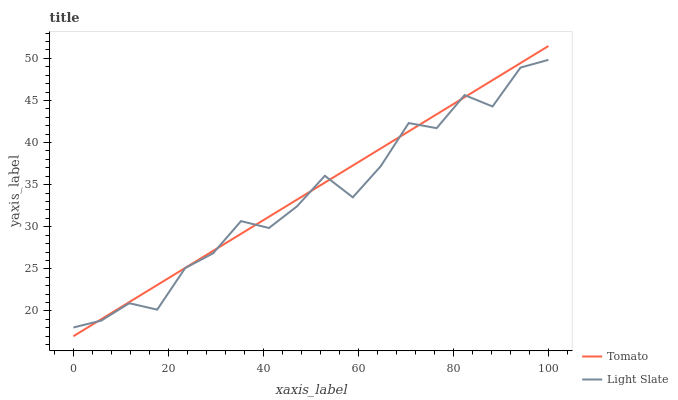Does Light Slate have the minimum area under the curve?
Answer yes or no. Yes. Does Tomato have the maximum area under the curve?
Answer yes or no. Yes. Does Light Slate have the maximum area under the curve?
Answer yes or no. No. Is Tomato the smoothest?
Answer yes or no. Yes. Is Light Slate the roughest?
Answer yes or no. Yes. Is Light Slate the smoothest?
Answer yes or no. No. Does Light Slate have the lowest value?
Answer yes or no. No. Does Light Slate have the highest value?
Answer yes or no. No. 